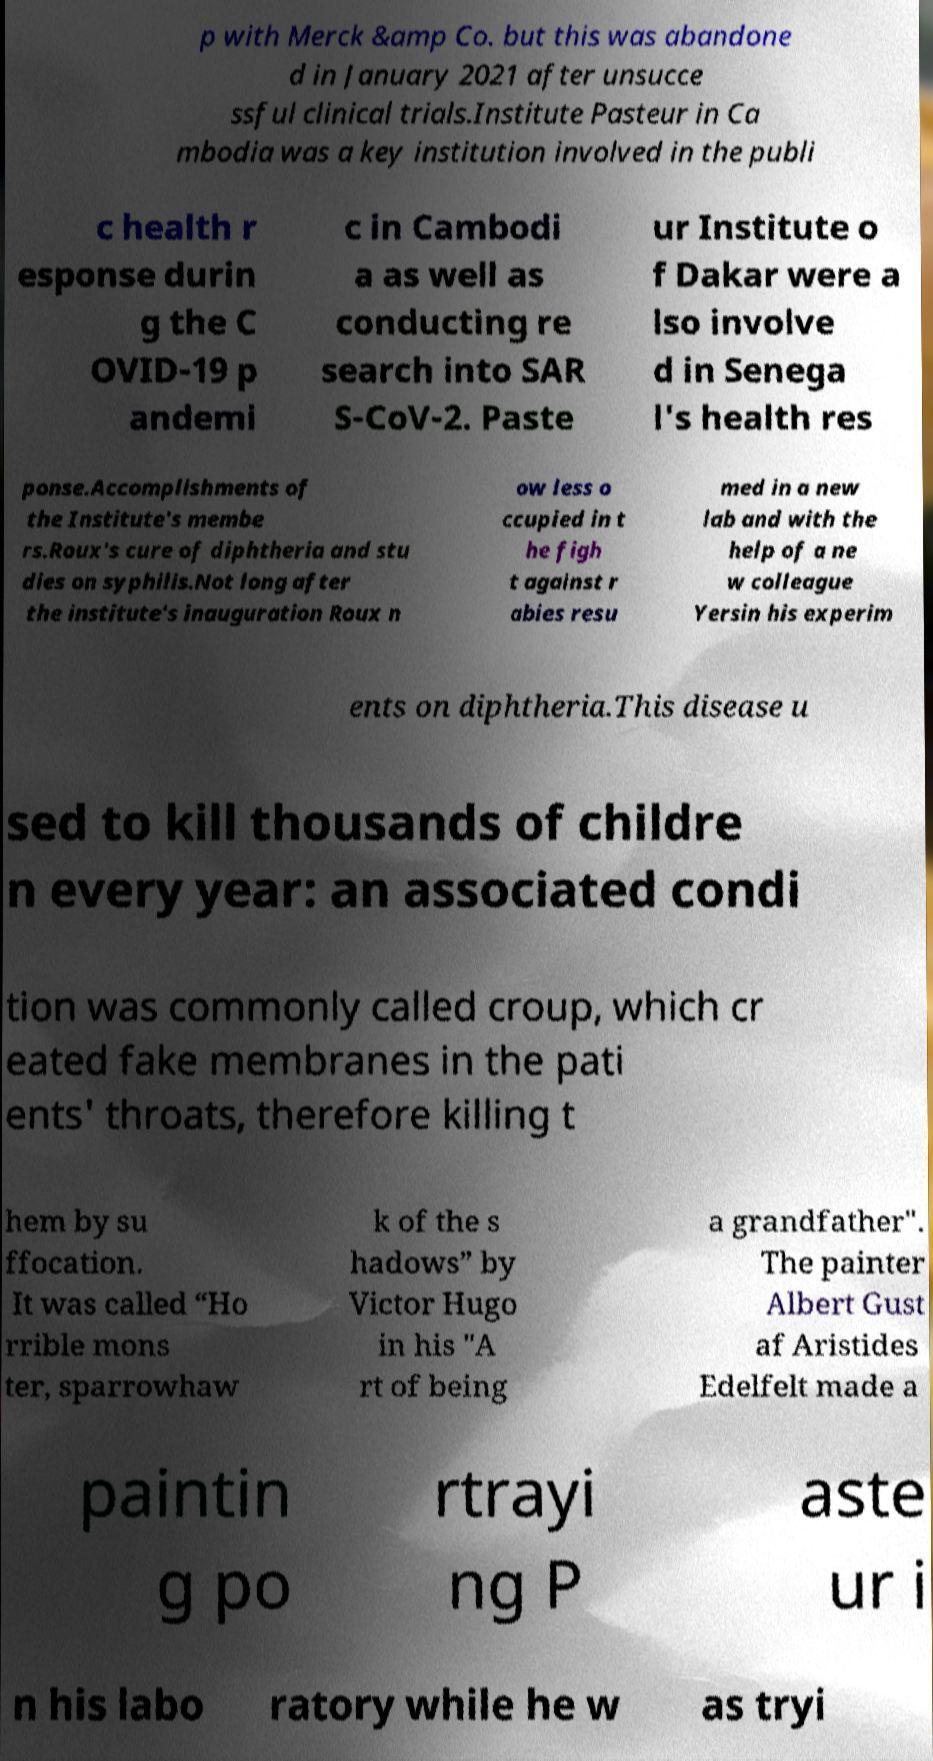Could you assist in decoding the text presented in this image and type it out clearly? p with Merck &amp Co. but this was abandone d in January 2021 after unsucce ssful clinical trials.Institute Pasteur in Ca mbodia was a key institution involved in the publi c health r esponse durin g the C OVID-19 p andemi c in Cambodi a as well as conducting re search into SAR S-CoV-2. Paste ur Institute o f Dakar were a lso involve d in Senega l's health res ponse.Accomplishments of the Institute's membe rs.Roux's cure of diphtheria and stu dies on syphilis.Not long after the institute's inauguration Roux n ow less o ccupied in t he figh t against r abies resu med in a new lab and with the help of a ne w colleague Yersin his experim ents on diphtheria.This disease u sed to kill thousands of childre n every year: an associated condi tion was commonly called croup, which cr eated fake membranes in the pati ents' throats, therefore killing t hem by su ffocation. It was called “Ho rrible mons ter, sparrowhaw k of the s hadows” by Victor Hugo in his "A rt of being a grandfather". The painter Albert Gust af Aristides Edelfelt made a paintin g po rtrayi ng P aste ur i n his labo ratory while he w as tryi 